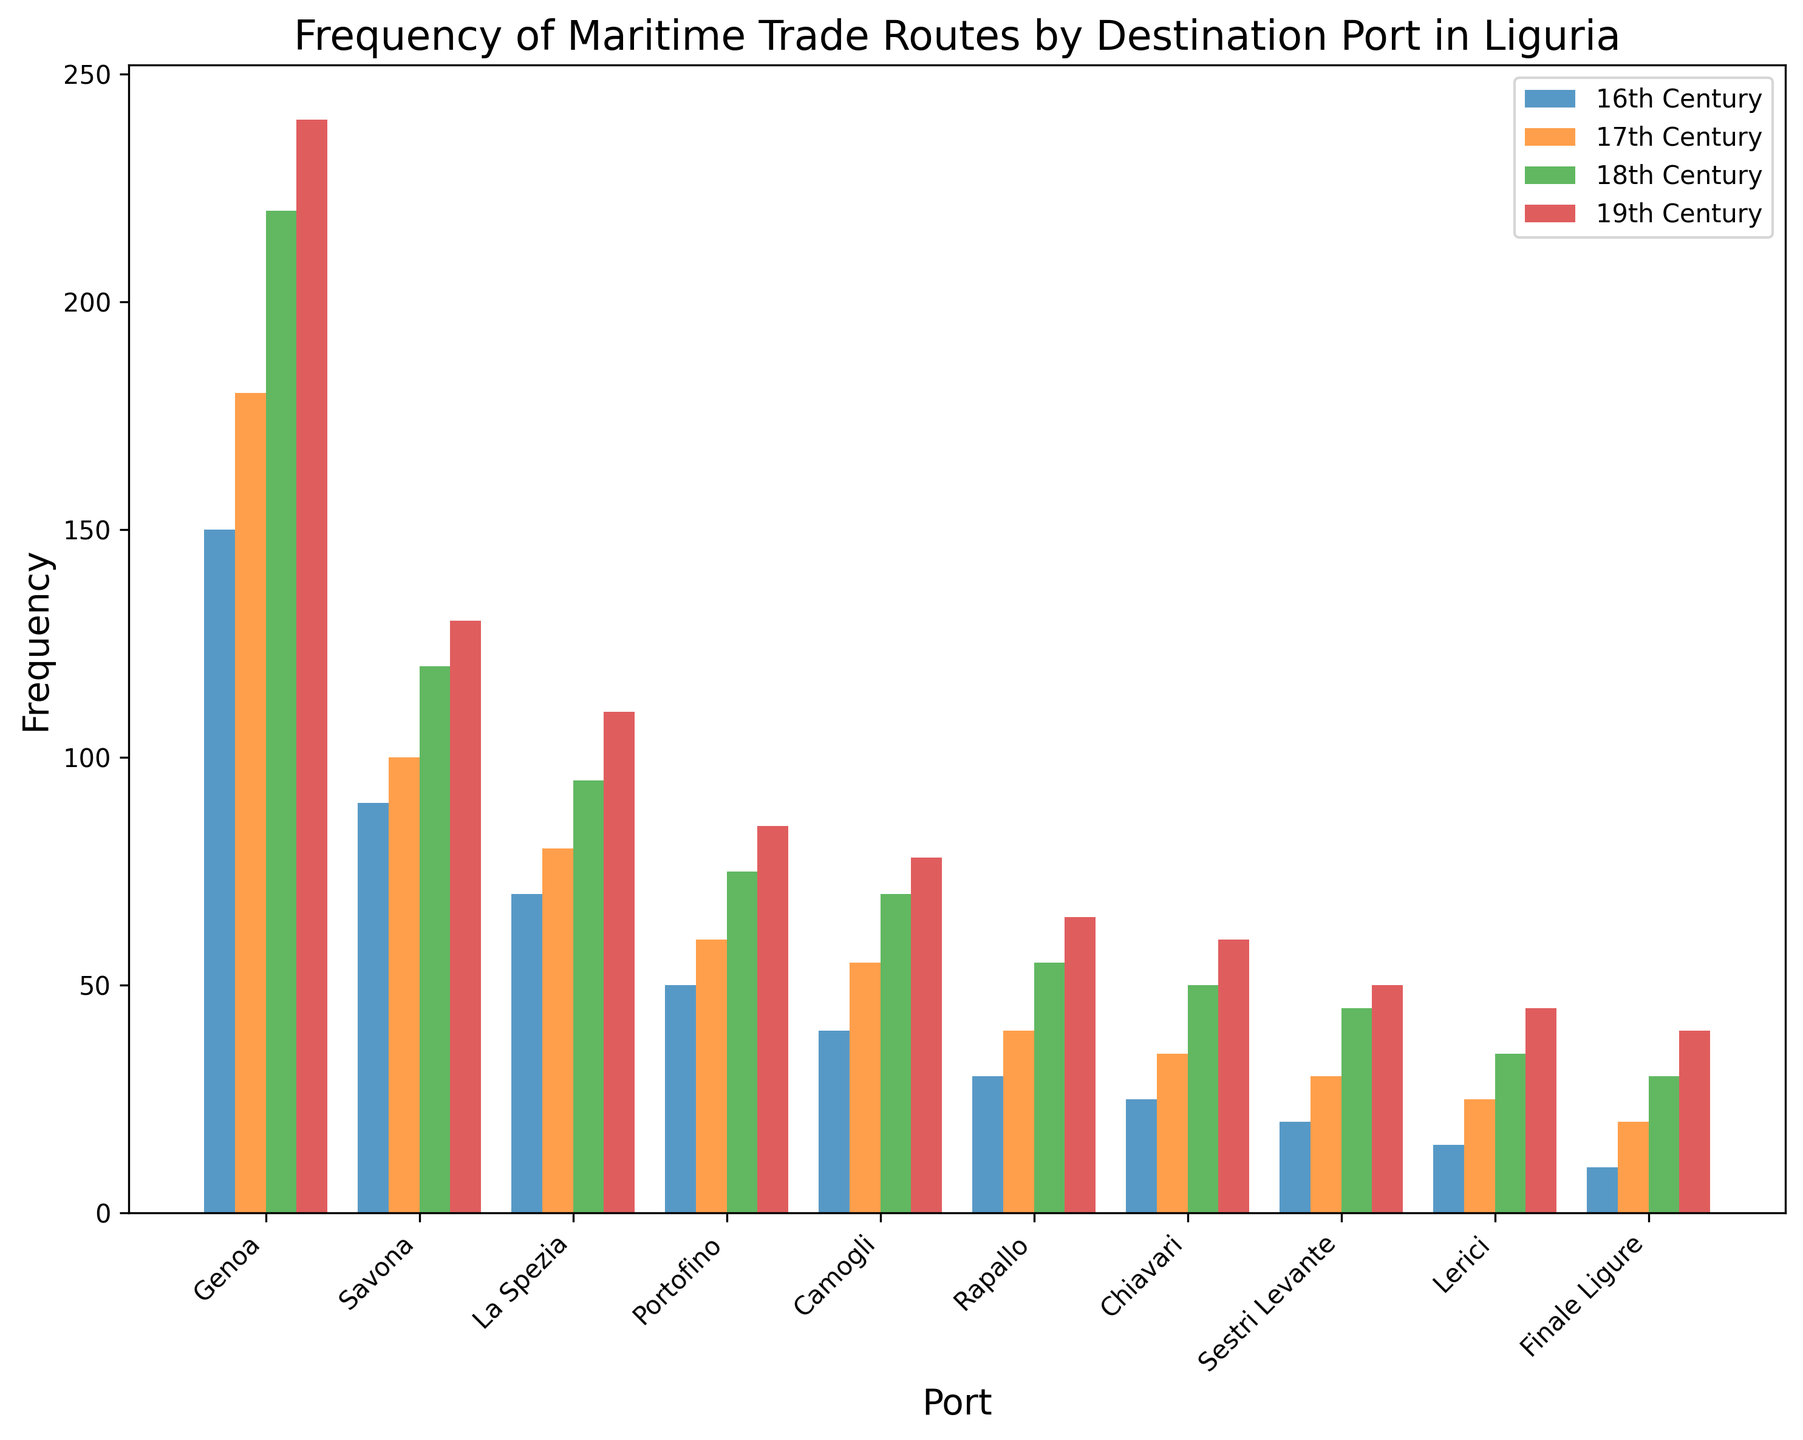Which port had the highest frequency of maritime trade routes in the 19th Century? First, locate the bars for the 19th Century. Identify the tallest bar among them. Genoa has the highest bar in the 19th Century.
Answer: Genoa What is the combined frequency of maritime trade routes for Savona across all centuries represented in the chart? Add the frequencies for Savona for each century: 90 (16th) + 100 (17th) + 120 (18th) + 130 (19th). The total is 440.
Answer: 440 Which century saw the highest increase in maritime trade route frequency for Portofino compared to the previous century? Calculate the differences between each consecutive century for Portofino: 60 - 50 = 10 (from 16th to 17th), 75 - 60 = 15 (from 17th to 18th), 85 - 75 = 10 (from 18th to 19th). The highest increase of 15 is from the 17th to the 18th century.
Answer: 17th to 18th Century Compare the trade frequencies of Rapallo and Chiavari in the 18th Century. Which port had a higher frequency, and by how much? Check the bar heights for Rapallo and Chiavari in the 18th Century. Rapallo: 55, Chiavari: 50. The difference is 55 - 50 = 5. Rapallo had a higher frequency by 5.
Answer: Rapallo by 5 What's the sum of the frequencies for Genova and La Spezia in the 16th Century? Identify the frequencies for Genoa and La Spezia in the 16th Century: 150 (Genoa) + 70 (La Spezia). The total is 220.
Answer: 220 Which ports had a frequency of maritime trade routes greater than 50 in the 17th Century? Examine the bars representing the 17th Century. Ports with frequencies greater than 50 are Genoa, Savona, La Spezia, Portofino, and Camogli.
Answer: Genoa, Savona, La Spezia, Portofino, Camogli What is the average frequency of maritime trade routes for Chiavari across all four centuries? Sum the frequencies for Chiavari for each century: 25 (16th) + 35 (17th) + 50 (18th) + 60 (19th). The total is 170. The average is 170/4 = 42.5.
Answer: 42.5 During which century did Lerici experience the highest frequency of maritime trade routes? Look at the bars representing each century for Lerici and identify the tallest one. The tallest bar is in the 19th Century.
Answer: 19th Century How does the frequency of maritime trade routes for Genoa in the 16th Century compare to Lerici across all four centuries? Compare the frequency for Genoa in the 16th Century (150) to the sum of frequencies for Lerici in all four centuries: 15 + 25 + 35 + 45 = 120. Genoa in the 16th Century (150) is greater than Lerici's total (120).
Answer: Greater by 30 After which century did Savona see no periods of frequency decline? Examine the frequencies for Savona across the centuries. 90 (16th) to 100 (17th), 100 (17th) to 120 (18th), 120 (18th) to 130 (19th). Savona saw continuous increase after the 16th Century.
Answer: After the 16th Century 